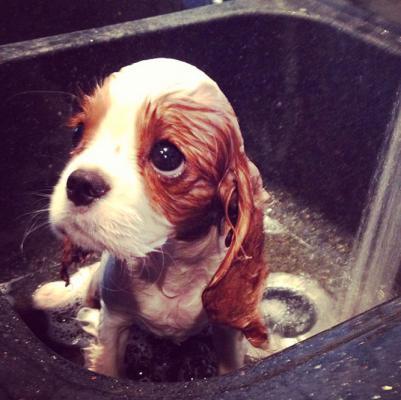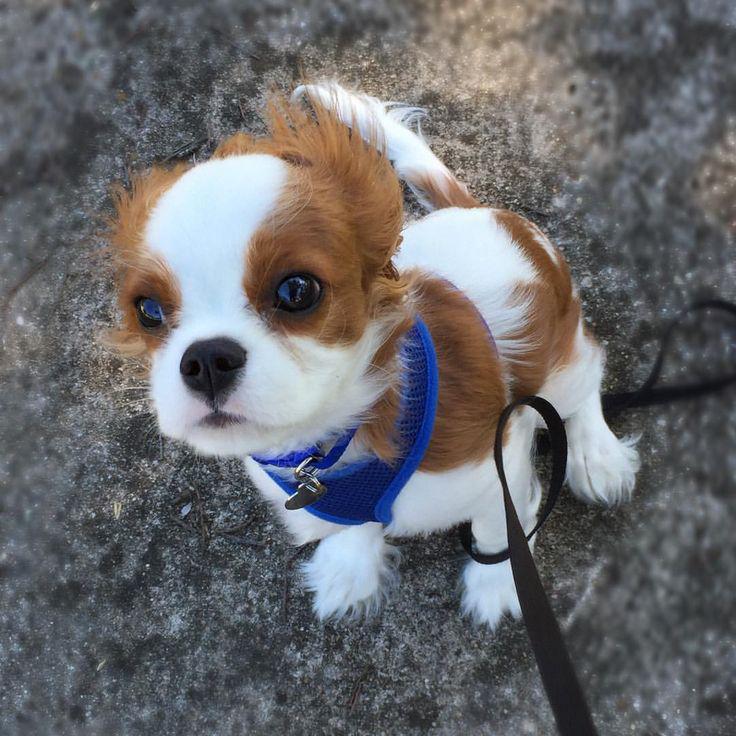The first image is the image on the left, the second image is the image on the right. Examine the images to the left and right. Is the description "The dog in the image on the right is lying down." accurate? Answer yes or no. No. The first image is the image on the left, the second image is the image on the right. Considering the images on both sides, is "One image shows a spaniel puppy inside a soft-sided pet bed, with its head upright instead of draped over the edge." valid? Answer yes or no. No. 